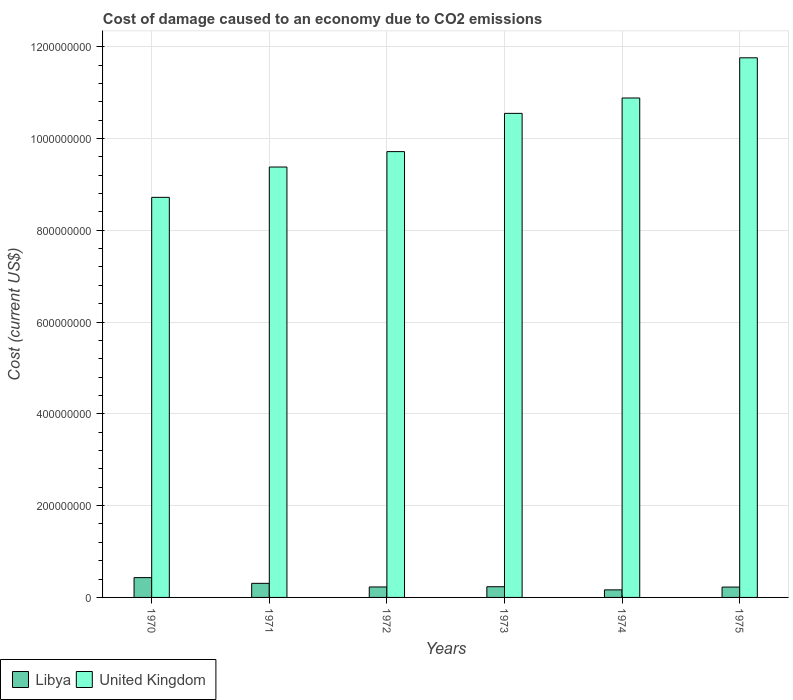How many groups of bars are there?
Make the answer very short. 6. Are the number of bars on each tick of the X-axis equal?
Ensure brevity in your answer.  Yes. How many bars are there on the 2nd tick from the right?
Your answer should be compact. 2. What is the label of the 5th group of bars from the left?
Your answer should be very brief. 1974. In how many cases, is the number of bars for a given year not equal to the number of legend labels?
Your answer should be compact. 0. What is the cost of damage caused due to CO2 emissisons in United Kingdom in 1972?
Your answer should be compact. 9.71e+08. Across all years, what is the maximum cost of damage caused due to CO2 emissisons in Libya?
Offer a terse response. 4.32e+07. Across all years, what is the minimum cost of damage caused due to CO2 emissisons in Libya?
Offer a very short reply. 1.65e+07. In which year was the cost of damage caused due to CO2 emissisons in Libya maximum?
Make the answer very short. 1970. In which year was the cost of damage caused due to CO2 emissisons in Libya minimum?
Your response must be concise. 1974. What is the total cost of damage caused due to CO2 emissisons in Libya in the graph?
Offer a very short reply. 1.59e+08. What is the difference between the cost of damage caused due to CO2 emissisons in Libya in 1972 and that in 1973?
Make the answer very short. -4.93e+05. What is the difference between the cost of damage caused due to CO2 emissisons in Libya in 1975 and the cost of damage caused due to CO2 emissisons in United Kingdom in 1971?
Your answer should be compact. -9.15e+08. What is the average cost of damage caused due to CO2 emissisons in United Kingdom per year?
Keep it short and to the point. 1.02e+09. In the year 1972, what is the difference between the cost of damage caused due to CO2 emissisons in Libya and cost of damage caused due to CO2 emissisons in United Kingdom?
Offer a very short reply. -9.49e+08. In how many years, is the cost of damage caused due to CO2 emissisons in United Kingdom greater than 280000000 US$?
Ensure brevity in your answer.  6. What is the ratio of the cost of damage caused due to CO2 emissisons in Libya in 1972 to that in 1975?
Your answer should be very brief. 1.01. Is the difference between the cost of damage caused due to CO2 emissisons in Libya in 1972 and 1973 greater than the difference between the cost of damage caused due to CO2 emissisons in United Kingdom in 1972 and 1973?
Provide a short and direct response. Yes. What is the difference between the highest and the second highest cost of damage caused due to CO2 emissisons in Libya?
Your response must be concise. 1.24e+07. What is the difference between the highest and the lowest cost of damage caused due to CO2 emissisons in Libya?
Your answer should be very brief. 2.67e+07. In how many years, is the cost of damage caused due to CO2 emissisons in Libya greater than the average cost of damage caused due to CO2 emissisons in Libya taken over all years?
Your answer should be compact. 2. Is the sum of the cost of damage caused due to CO2 emissisons in Libya in 1973 and 1974 greater than the maximum cost of damage caused due to CO2 emissisons in United Kingdom across all years?
Your answer should be very brief. No. What does the 2nd bar from the right in 1972 represents?
Your response must be concise. Libya. How many bars are there?
Your answer should be very brief. 12. Does the graph contain any zero values?
Ensure brevity in your answer.  No. How are the legend labels stacked?
Your answer should be compact. Horizontal. What is the title of the graph?
Your answer should be very brief. Cost of damage caused to an economy due to CO2 emissions. What is the label or title of the Y-axis?
Ensure brevity in your answer.  Cost (current US$). What is the Cost (current US$) of Libya in 1970?
Provide a succinct answer. 4.32e+07. What is the Cost (current US$) in United Kingdom in 1970?
Make the answer very short. 8.72e+08. What is the Cost (current US$) in Libya in 1971?
Give a very brief answer. 3.07e+07. What is the Cost (current US$) of United Kingdom in 1971?
Ensure brevity in your answer.  9.38e+08. What is the Cost (current US$) of Libya in 1972?
Your answer should be compact. 2.28e+07. What is the Cost (current US$) in United Kingdom in 1972?
Your answer should be compact. 9.71e+08. What is the Cost (current US$) in Libya in 1973?
Provide a succinct answer. 2.33e+07. What is the Cost (current US$) in United Kingdom in 1973?
Provide a succinct answer. 1.05e+09. What is the Cost (current US$) of Libya in 1974?
Provide a succinct answer. 1.65e+07. What is the Cost (current US$) of United Kingdom in 1974?
Give a very brief answer. 1.09e+09. What is the Cost (current US$) of Libya in 1975?
Keep it short and to the point. 2.26e+07. What is the Cost (current US$) in United Kingdom in 1975?
Ensure brevity in your answer.  1.18e+09. Across all years, what is the maximum Cost (current US$) in Libya?
Make the answer very short. 4.32e+07. Across all years, what is the maximum Cost (current US$) in United Kingdom?
Your answer should be very brief. 1.18e+09. Across all years, what is the minimum Cost (current US$) of Libya?
Ensure brevity in your answer.  1.65e+07. Across all years, what is the minimum Cost (current US$) in United Kingdom?
Offer a very short reply. 8.72e+08. What is the total Cost (current US$) in Libya in the graph?
Your answer should be compact. 1.59e+08. What is the total Cost (current US$) in United Kingdom in the graph?
Ensure brevity in your answer.  6.10e+09. What is the difference between the Cost (current US$) of Libya in 1970 and that in 1971?
Make the answer very short. 1.24e+07. What is the difference between the Cost (current US$) in United Kingdom in 1970 and that in 1971?
Offer a very short reply. -6.61e+07. What is the difference between the Cost (current US$) in Libya in 1970 and that in 1972?
Provide a succinct answer. 2.03e+07. What is the difference between the Cost (current US$) of United Kingdom in 1970 and that in 1972?
Give a very brief answer. -9.97e+07. What is the difference between the Cost (current US$) of Libya in 1970 and that in 1973?
Keep it short and to the point. 1.98e+07. What is the difference between the Cost (current US$) in United Kingdom in 1970 and that in 1973?
Provide a succinct answer. -1.83e+08. What is the difference between the Cost (current US$) in Libya in 1970 and that in 1974?
Make the answer very short. 2.67e+07. What is the difference between the Cost (current US$) in United Kingdom in 1970 and that in 1974?
Provide a short and direct response. -2.16e+08. What is the difference between the Cost (current US$) in Libya in 1970 and that in 1975?
Make the answer very short. 2.06e+07. What is the difference between the Cost (current US$) of United Kingdom in 1970 and that in 1975?
Provide a short and direct response. -3.04e+08. What is the difference between the Cost (current US$) in Libya in 1971 and that in 1972?
Make the answer very short. 7.90e+06. What is the difference between the Cost (current US$) in United Kingdom in 1971 and that in 1972?
Make the answer very short. -3.36e+07. What is the difference between the Cost (current US$) in Libya in 1971 and that in 1973?
Ensure brevity in your answer.  7.41e+06. What is the difference between the Cost (current US$) in United Kingdom in 1971 and that in 1973?
Keep it short and to the point. -1.17e+08. What is the difference between the Cost (current US$) of Libya in 1971 and that in 1974?
Your response must be concise. 1.42e+07. What is the difference between the Cost (current US$) of United Kingdom in 1971 and that in 1974?
Keep it short and to the point. -1.50e+08. What is the difference between the Cost (current US$) of Libya in 1971 and that in 1975?
Your response must be concise. 8.16e+06. What is the difference between the Cost (current US$) of United Kingdom in 1971 and that in 1975?
Make the answer very short. -2.38e+08. What is the difference between the Cost (current US$) of Libya in 1972 and that in 1973?
Give a very brief answer. -4.93e+05. What is the difference between the Cost (current US$) of United Kingdom in 1972 and that in 1973?
Offer a very short reply. -8.33e+07. What is the difference between the Cost (current US$) in Libya in 1972 and that in 1974?
Offer a terse response. 6.35e+06. What is the difference between the Cost (current US$) in United Kingdom in 1972 and that in 1974?
Offer a very short reply. -1.17e+08. What is the difference between the Cost (current US$) in Libya in 1972 and that in 1975?
Provide a short and direct response. 2.61e+05. What is the difference between the Cost (current US$) of United Kingdom in 1972 and that in 1975?
Provide a short and direct response. -2.04e+08. What is the difference between the Cost (current US$) of Libya in 1973 and that in 1974?
Offer a very short reply. 6.84e+06. What is the difference between the Cost (current US$) of United Kingdom in 1973 and that in 1974?
Your answer should be compact. -3.35e+07. What is the difference between the Cost (current US$) in Libya in 1973 and that in 1975?
Provide a short and direct response. 7.54e+05. What is the difference between the Cost (current US$) in United Kingdom in 1973 and that in 1975?
Your response must be concise. -1.21e+08. What is the difference between the Cost (current US$) of Libya in 1974 and that in 1975?
Make the answer very short. -6.09e+06. What is the difference between the Cost (current US$) of United Kingdom in 1974 and that in 1975?
Provide a short and direct response. -8.76e+07. What is the difference between the Cost (current US$) of Libya in 1970 and the Cost (current US$) of United Kingdom in 1971?
Offer a terse response. -8.95e+08. What is the difference between the Cost (current US$) in Libya in 1970 and the Cost (current US$) in United Kingdom in 1972?
Your answer should be compact. -9.28e+08. What is the difference between the Cost (current US$) in Libya in 1970 and the Cost (current US$) in United Kingdom in 1973?
Your answer should be compact. -1.01e+09. What is the difference between the Cost (current US$) in Libya in 1970 and the Cost (current US$) in United Kingdom in 1974?
Provide a succinct answer. -1.05e+09. What is the difference between the Cost (current US$) in Libya in 1970 and the Cost (current US$) in United Kingdom in 1975?
Offer a very short reply. -1.13e+09. What is the difference between the Cost (current US$) in Libya in 1971 and the Cost (current US$) in United Kingdom in 1972?
Give a very brief answer. -9.41e+08. What is the difference between the Cost (current US$) in Libya in 1971 and the Cost (current US$) in United Kingdom in 1973?
Ensure brevity in your answer.  -1.02e+09. What is the difference between the Cost (current US$) of Libya in 1971 and the Cost (current US$) of United Kingdom in 1974?
Keep it short and to the point. -1.06e+09. What is the difference between the Cost (current US$) of Libya in 1971 and the Cost (current US$) of United Kingdom in 1975?
Offer a terse response. -1.15e+09. What is the difference between the Cost (current US$) in Libya in 1972 and the Cost (current US$) in United Kingdom in 1973?
Your answer should be compact. -1.03e+09. What is the difference between the Cost (current US$) of Libya in 1972 and the Cost (current US$) of United Kingdom in 1974?
Offer a terse response. -1.07e+09. What is the difference between the Cost (current US$) in Libya in 1972 and the Cost (current US$) in United Kingdom in 1975?
Provide a succinct answer. -1.15e+09. What is the difference between the Cost (current US$) of Libya in 1973 and the Cost (current US$) of United Kingdom in 1974?
Give a very brief answer. -1.06e+09. What is the difference between the Cost (current US$) of Libya in 1973 and the Cost (current US$) of United Kingdom in 1975?
Your answer should be compact. -1.15e+09. What is the difference between the Cost (current US$) of Libya in 1974 and the Cost (current US$) of United Kingdom in 1975?
Your answer should be compact. -1.16e+09. What is the average Cost (current US$) in Libya per year?
Provide a succinct answer. 2.65e+07. What is the average Cost (current US$) of United Kingdom per year?
Keep it short and to the point. 1.02e+09. In the year 1970, what is the difference between the Cost (current US$) of Libya and Cost (current US$) of United Kingdom?
Provide a short and direct response. -8.29e+08. In the year 1971, what is the difference between the Cost (current US$) in Libya and Cost (current US$) in United Kingdom?
Offer a terse response. -9.07e+08. In the year 1972, what is the difference between the Cost (current US$) in Libya and Cost (current US$) in United Kingdom?
Your answer should be very brief. -9.49e+08. In the year 1973, what is the difference between the Cost (current US$) of Libya and Cost (current US$) of United Kingdom?
Make the answer very short. -1.03e+09. In the year 1974, what is the difference between the Cost (current US$) of Libya and Cost (current US$) of United Kingdom?
Your response must be concise. -1.07e+09. In the year 1975, what is the difference between the Cost (current US$) in Libya and Cost (current US$) in United Kingdom?
Your answer should be compact. -1.15e+09. What is the ratio of the Cost (current US$) of Libya in 1970 to that in 1971?
Provide a short and direct response. 1.41. What is the ratio of the Cost (current US$) in United Kingdom in 1970 to that in 1971?
Provide a short and direct response. 0.93. What is the ratio of the Cost (current US$) in Libya in 1970 to that in 1972?
Your answer should be compact. 1.89. What is the ratio of the Cost (current US$) in United Kingdom in 1970 to that in 1972?
Offer a very short reply. 0.9. What is the ratio of the Cost (current US$) in Libya in 1970 to that in 1973?
Offer a terse response. 1.85. What is the ratio of the Cost (current US$) of United Kingdom in 1970 to that in 1973?
Offer a terse response. 0.83. What is the ratio of the Cost (current US$) of Libya in 1970 to that in 1974?
Offer a very short reply. 2.62. What is the ratio of the Cost (current US$) in United Kingdom in 1970 to that in 1974?
Provide a succinct answer. 0.8. What is the ratio of the Cost (current US$) in Libya in 1970 to that in 1975?
Keep it short and to the point. 1.91. What is the ratio of the Cost (current US$) in United Kingdom in 1970 to that in 1975?
Offer a very short reply. 0.74. What is the ratio of the Cost (current US$) in Libya in 1971 to that in 1972?
Offer a very short reply. 1.35. What is the ratio of the Cost (current US$) in United Kingdom in 1971 to that in 1972?
Your answer should be compact. 0.97. What is the ratio of the Cost (current US$) of Libya in 1971 to that in 1973?
Ensure brevity in your answer.  1.32. What is the ratio of the Cost (current US$) of United Kingdom in 1971 to that in 1973?
Ensure brevity in your answer.  0.89. What is the ratio of the Cost (current US$) in Libya in 1971 to that in 1974?
Your answer should be compact. 1.87. What is the ratio of the Cost (current US$) in United Kingdom in 1971 to that in 1974?
Your answer should be very brief. 0.86. What is the ratio of the Cost (current US$) of Libya in 1971 to that in 1975?
Ensure brevity in your answer.  1.36. What is the ratio of the Cost (current US$) in United Kingdom in 1971 to that in 1975?
Give a very brief answer. 0.8. What is the ratio of the Cost (current US$) of Libya in 1972 to that in 1973?
Offer a very short reply. 0.98. What is the ratio of the Cost (current US$) of United Kingdom in 1972 to that in 1973?
Provide a succinct answer. 0.92. What is the ratio of the Cost (current US$) in Libya in 1972 to that in 1974?
Ensure brevity in your answer.  1.39. What is the ratio of the Cost (current US$) of United Kingdom in 1972 to that in 1974?
Your answer should be compact. 0.89. What is the ratio of the Cost (current US$) in Libya in 1972 to that in 1975?
Provide a short and direct response. 1.01. What is the ratio of the Cost (current US$) of United Kingdom in 1972 to that in 1975?
Provide a short and direct response. 0.83. What is the ratio of the Cost (current US$) in Libya in 1973 to that in 1974?
Your answer should be very brief. 1.42. What is the ratio of the Cost (current US$) of United Kingdom in 1973 to that in 1974?
Ensure brevity in your answer.  0.97. What is the ratio of the Cost (current US$) in Libya in 1973 to that in 1975?
Provide a succinct answer. 1.03. What is the ratio of the Cost (current US$) in United Kingdom in 1973 to that in 1975?
Make the answer very short. 0.9. What is the ratio of the Cost (current US$) of Libya in 1974 to that in 1975?
Your answer should be compact. 0.73. What is the ratio of the Cost (current US$) in United Kingdom in 1974 to that in 1975?
Ensure brevity in your answer.  0.93. What is the difference between the highest and the second highest Cost (current US$) of Libya?
Keep it short and to the point. 1.24e+07. What is the difference between the highest and the second highest Cost (current US$) of United Kingdom?
Provide a short and direct response. 8.76e+07. What is the difference between the highest and the lowest Cost (current US$) in Libya?
Provide a succinct answer. 2.67e+07. What is the difference between the highest and the lowest Cost (current US$) in United Kingdom?
Your answer should be very brief. 3.04e+08. 